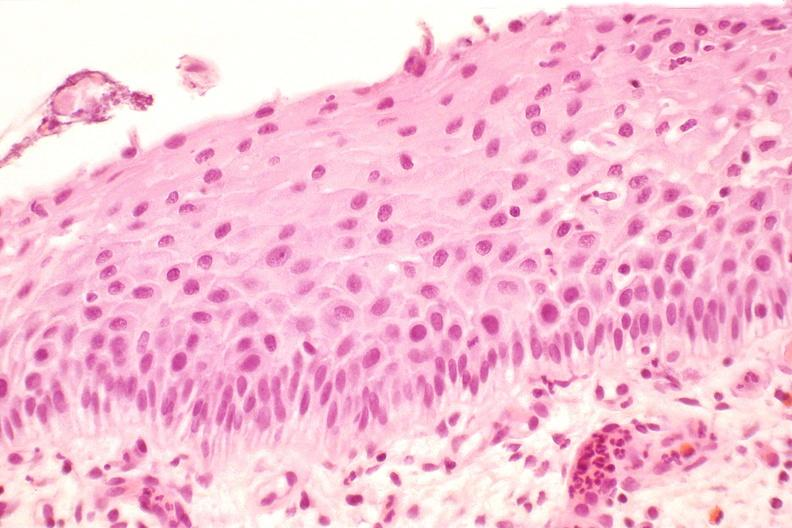does this image show cervix, mild dysplasia?
Answer the question using a single word or phrase. Yes 